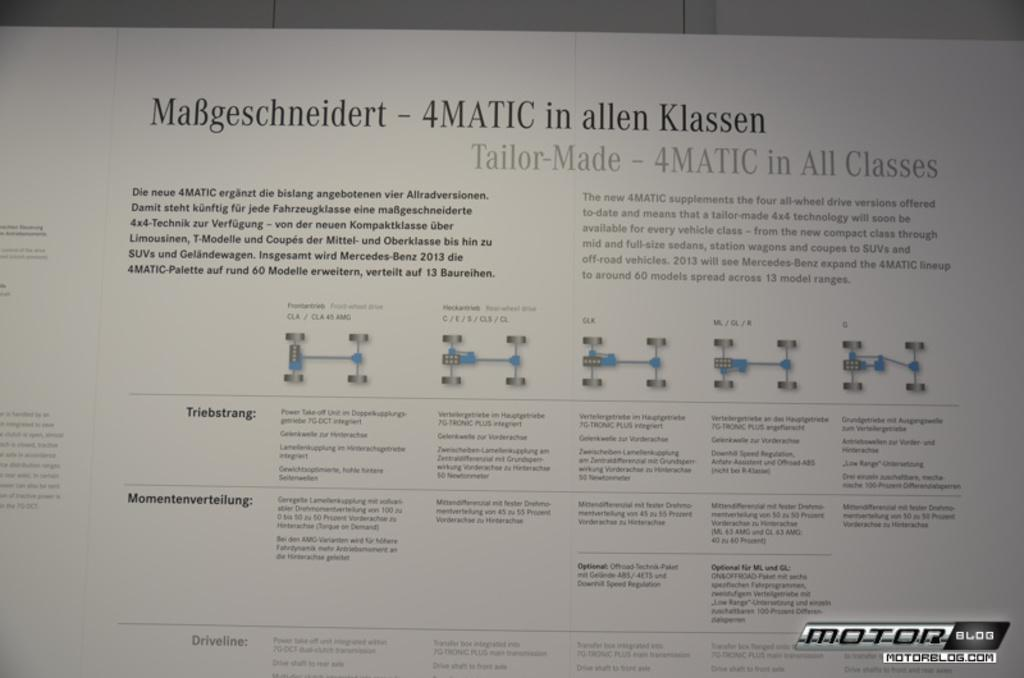<image>
Summarize the visual content of the image. the word Klassen is on the white paper 